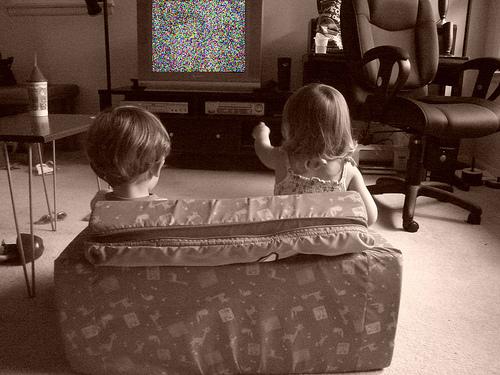Are the kids watching television?
Short answer required. Yes. How many kids are sitting down?
Concise answer only. 2. What are the kids watching?
Short answer required. Tv. 